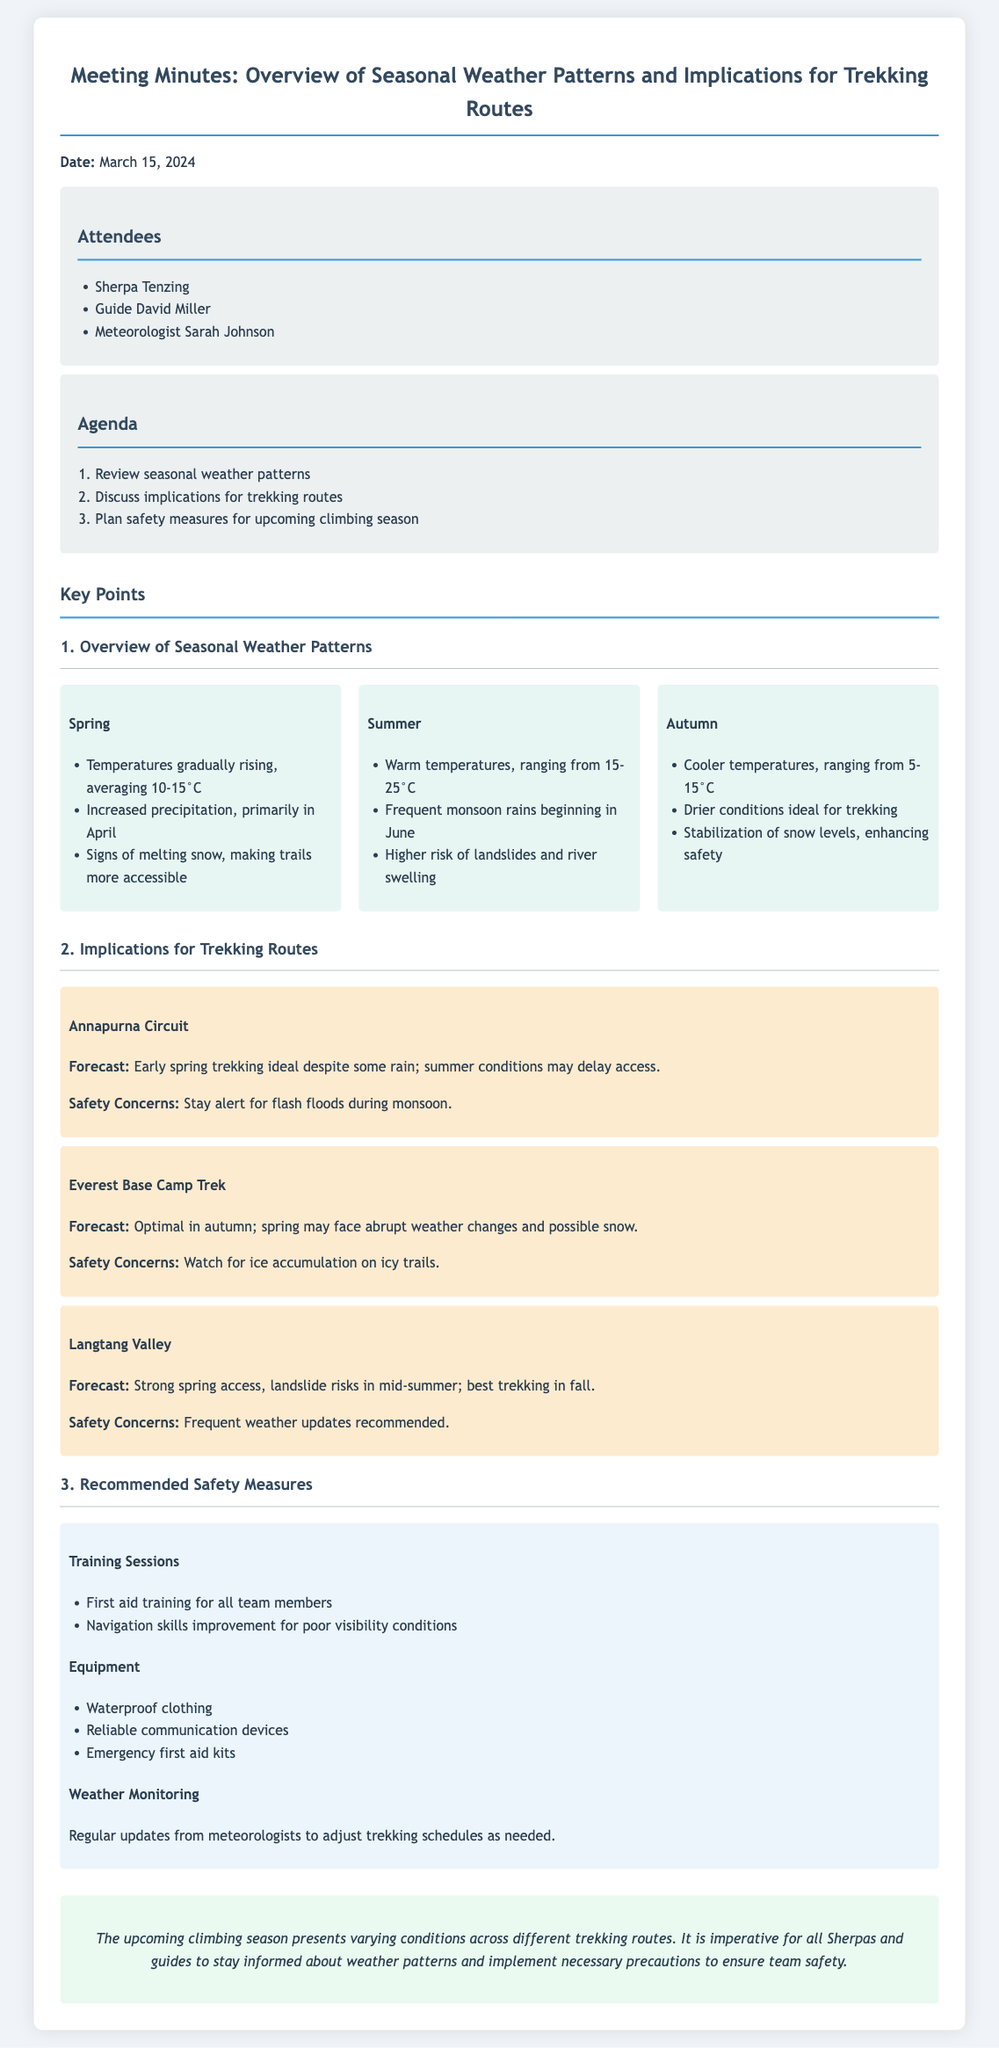What is the date of the meeting? The date of the meeting is mentioned at the beginning of the document.
Answer: March 15, 2024 Who attended the meeting? The document lists the attendees in a designated section.
Answer: Sherpa Tenzing, Guide David Miller, Meteorologist Sarah Johnson What is the average temperature in Spring? The average temperature for Spring is specified in the weather patterns section.
Answer: 10-15°C What is a safety concern for the Annapurna Circuit? The safety concerns for each trekking route are outlined in the implications section.
Answer: Flash floods during monsoon Which trekking route is optimal in autumn? The document provides forecasts for each trekking route, including the best season for each.
Answer: Everest Base Camp Trek What are the recommended first aid training topics? The document lists the training sessions under safety measures.
Answer: First aid training for all team members What type of clothing is recommended? The safety measures section specifies recommended equipment.
Answer: Waterproof clothing How often should weather updates be monitored? The document mentions this in the weather monitoring section under safety measures.
Answer: Regular updates 